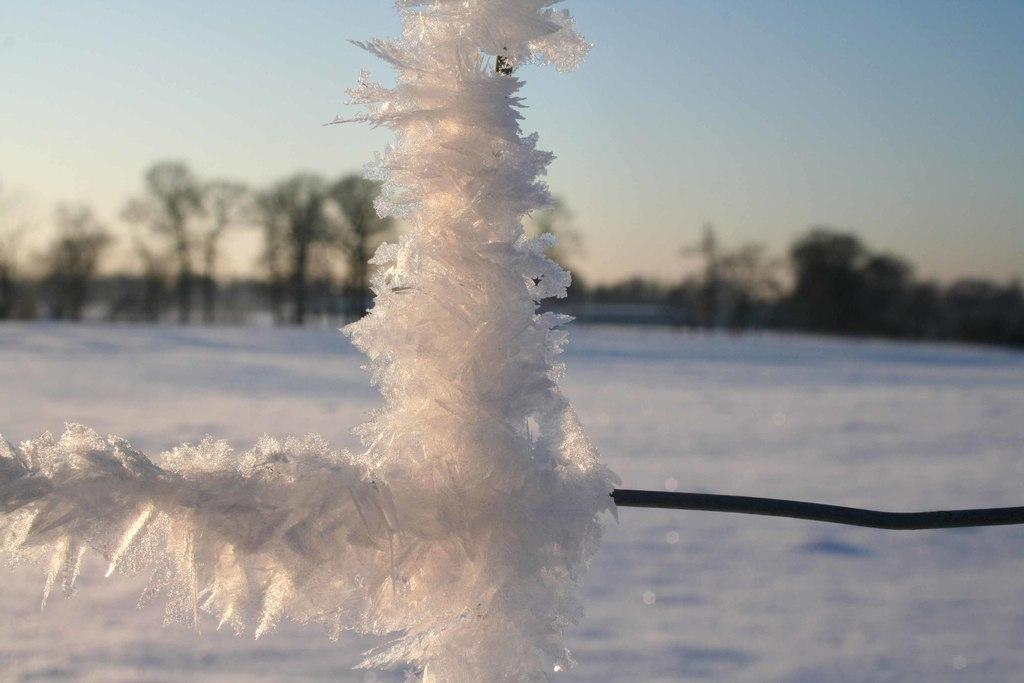What is on the wire that is visible in the image? There is snow on the wire in the image. What is the condition of the ground in the image? The ground is covered with snow in the image. What type of vegetation can be seen in the image? There is a group of trees visible in the image. What is the condition of the sky in the image? The sky is visible in the image and appears cloudy. What company is responsible for the snow in the image? There is no company responsible for the snow in the image; it is a natural occurrence. Can you see any waves in the image? There are no waves visible in the image, as it is a snowy landscape. 